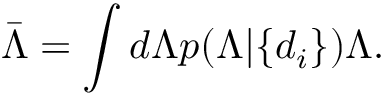<formula> <loc_0><loc_0><loc_500><loc_500>\bar { \Lambda } = \int d \Lambda p ( \Lambda | \{ d _ { i } \} ) \Lambda .</formula> 